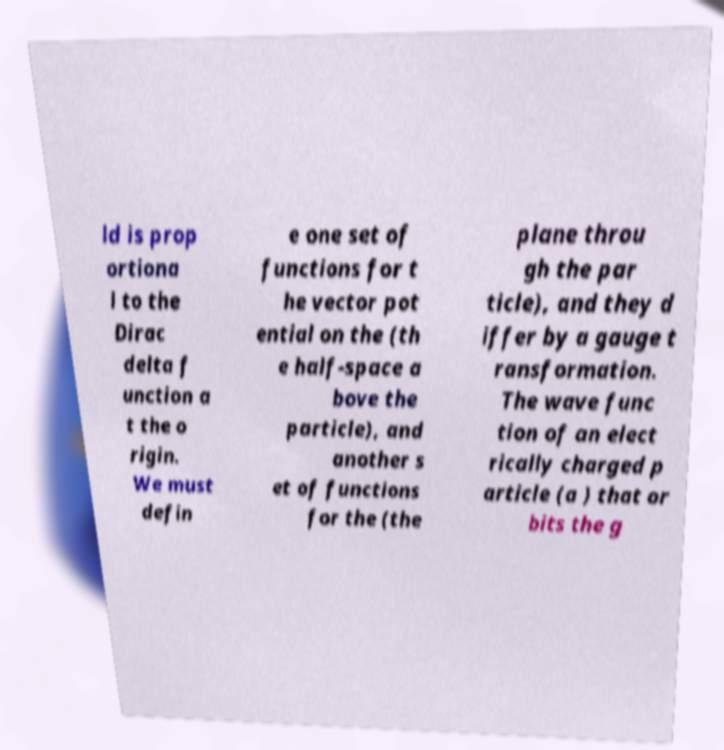Could you extract and type out the text from this image? ld is prop ortiona l to the Dirac delta f unction a t the o rigin. We must defin e one set of functions for t he vector pot ential on the (th e half-space a bove the particle), and another s et of functions for the (the plane throu gh the par ticle), and they d iffer by a gauge t ransformation. The wave func tion of an elect rically charged p article (a ) that or bits the g 